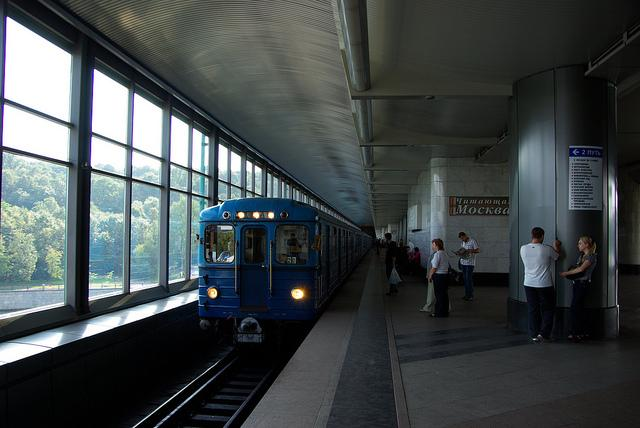What country is this location? russia 